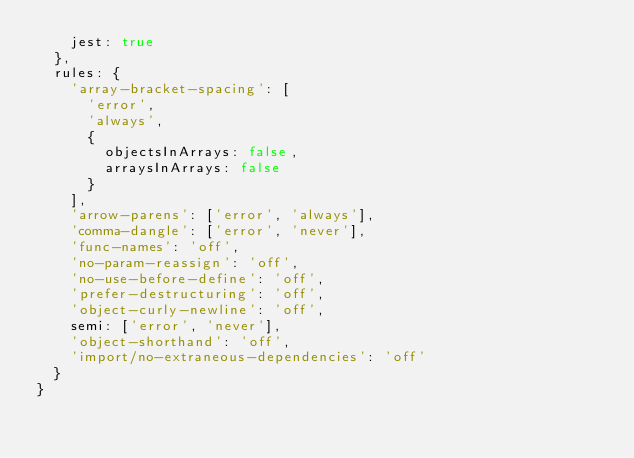Convert code to text. <code><loc_0><loc_0><loc_500><loc_500><_JavaScript_>    jest: true
  },
  rules: {
    'array-bracket-spacing': [
      'error',
      'always',
      {
        objectsInArrays: false,
        arraysInArrays: false
      }
    ],
    'arrow-parens': ['error', 'always'],
    'comma-dangle': ['error', 'never'],
    'func-names': 'off',
    'no-param-reassign': 'off',
    'no-use-before-define': 'off',
    'prefer-destructuring': 'off',
    'object-curly-newline': 'off',
    semi: ['error', 'never'],
    'object-shorthand': 'off',
    'import/no-extraneous-dependencies': 'off'
  }
}
</code> 